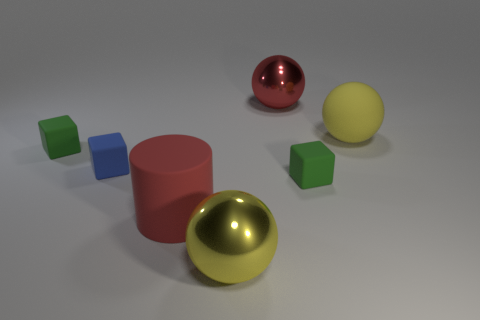Is the number of small green things that are left of the large red ball the same as the number of big rubber spheres?
Provide a short and direct response. Yes. Is there a tiny rubber cylinder that has the same color as the large cylinder?
Your response must be concise. No. Is the size of the red matte cylinder the same as the red sphere?
Offer a terse response. Yes. There is a yellow ball that is in front of the red thing that is on the left side of the big red ball; what is its size?
Offer a terse response. Large. There is a sphere that is in front of the red sphere and behind the matte cylinder; how big is it?
Offer a very short reply. Large. How many yellow balls are the same size as the yellow metallic thing?
Your response must be concise. 1. How many shiny things are cubes or spheres?
Keep it short and to the point. 2. The thing that is the same color as the big cylinder is what size?
Keep it short and to the point. Large. What material is the large yellow sphere that is in front of the green matte thing to the left of the yellow metallic object?
Your response must be concise. Metal. What number of things are red objects or big shiny objects behind the blue rubber object?
Keep it short and to the point. 2. 